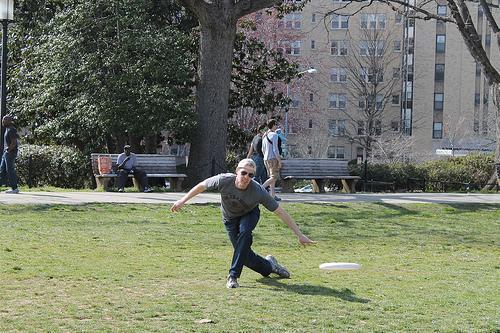How many people playing frisbee?
Give a very brief answer. 1. 